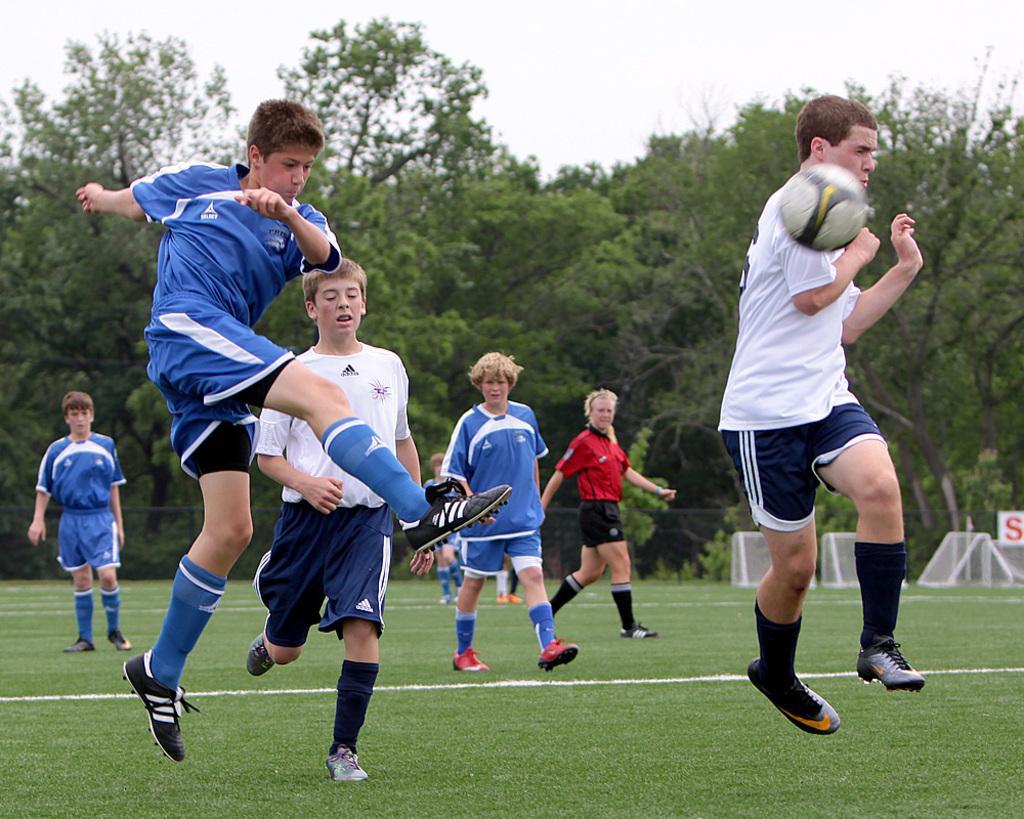How would you summarize this image in a sentence or two? This picture is taken inside a playground. In this image, on the right side, we can see a man wearing a white color shirt is jumping. On the right side, we can also see a football which is in the air. On the left side, wearing a blue color dress is jumping. In the background, we can see a group of people, trees. At the top, we can see a sky, at the bottom, we can see a grass. 